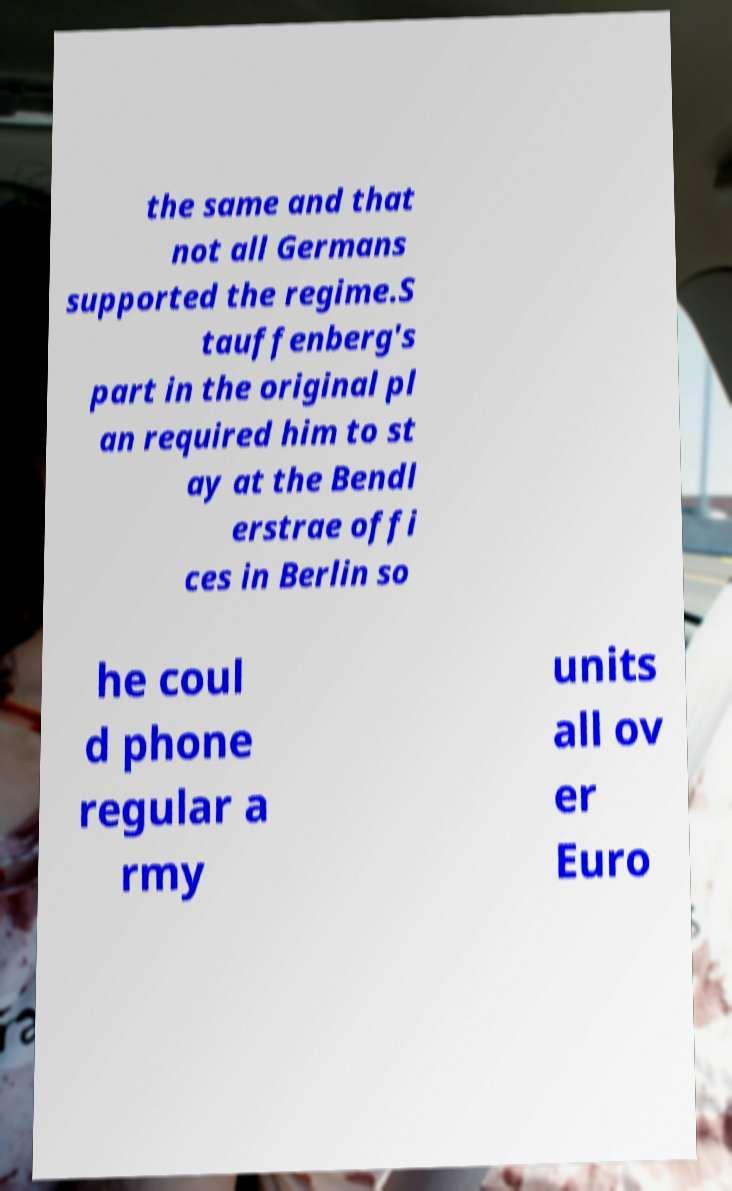Could you assist in decoding the text presented in this image and type it out clearly? the same and that not all Germans supported the regime.S tauffenberg's part in the original pl an required him to st ay at the Bendl erstrae offi ces in Berlin so he coul d phone regular a rmy units all ov er Euro 